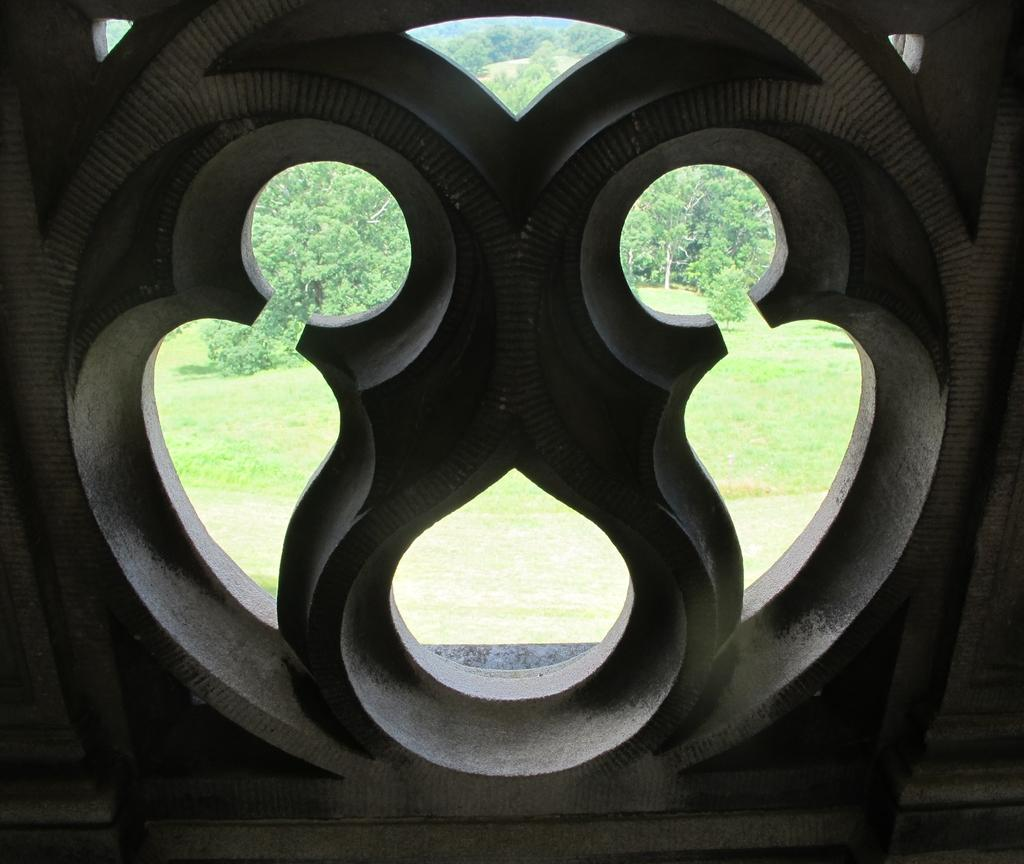What type of vegetation is present in the image? There is grass and trees in the image. Can you describe the natural environment depicted in the image? The image features grass and trees, which suggests a natural outdoor setting. What is the rate of the class in the image? There is no class or rate present in the image; it features grass and trees. 